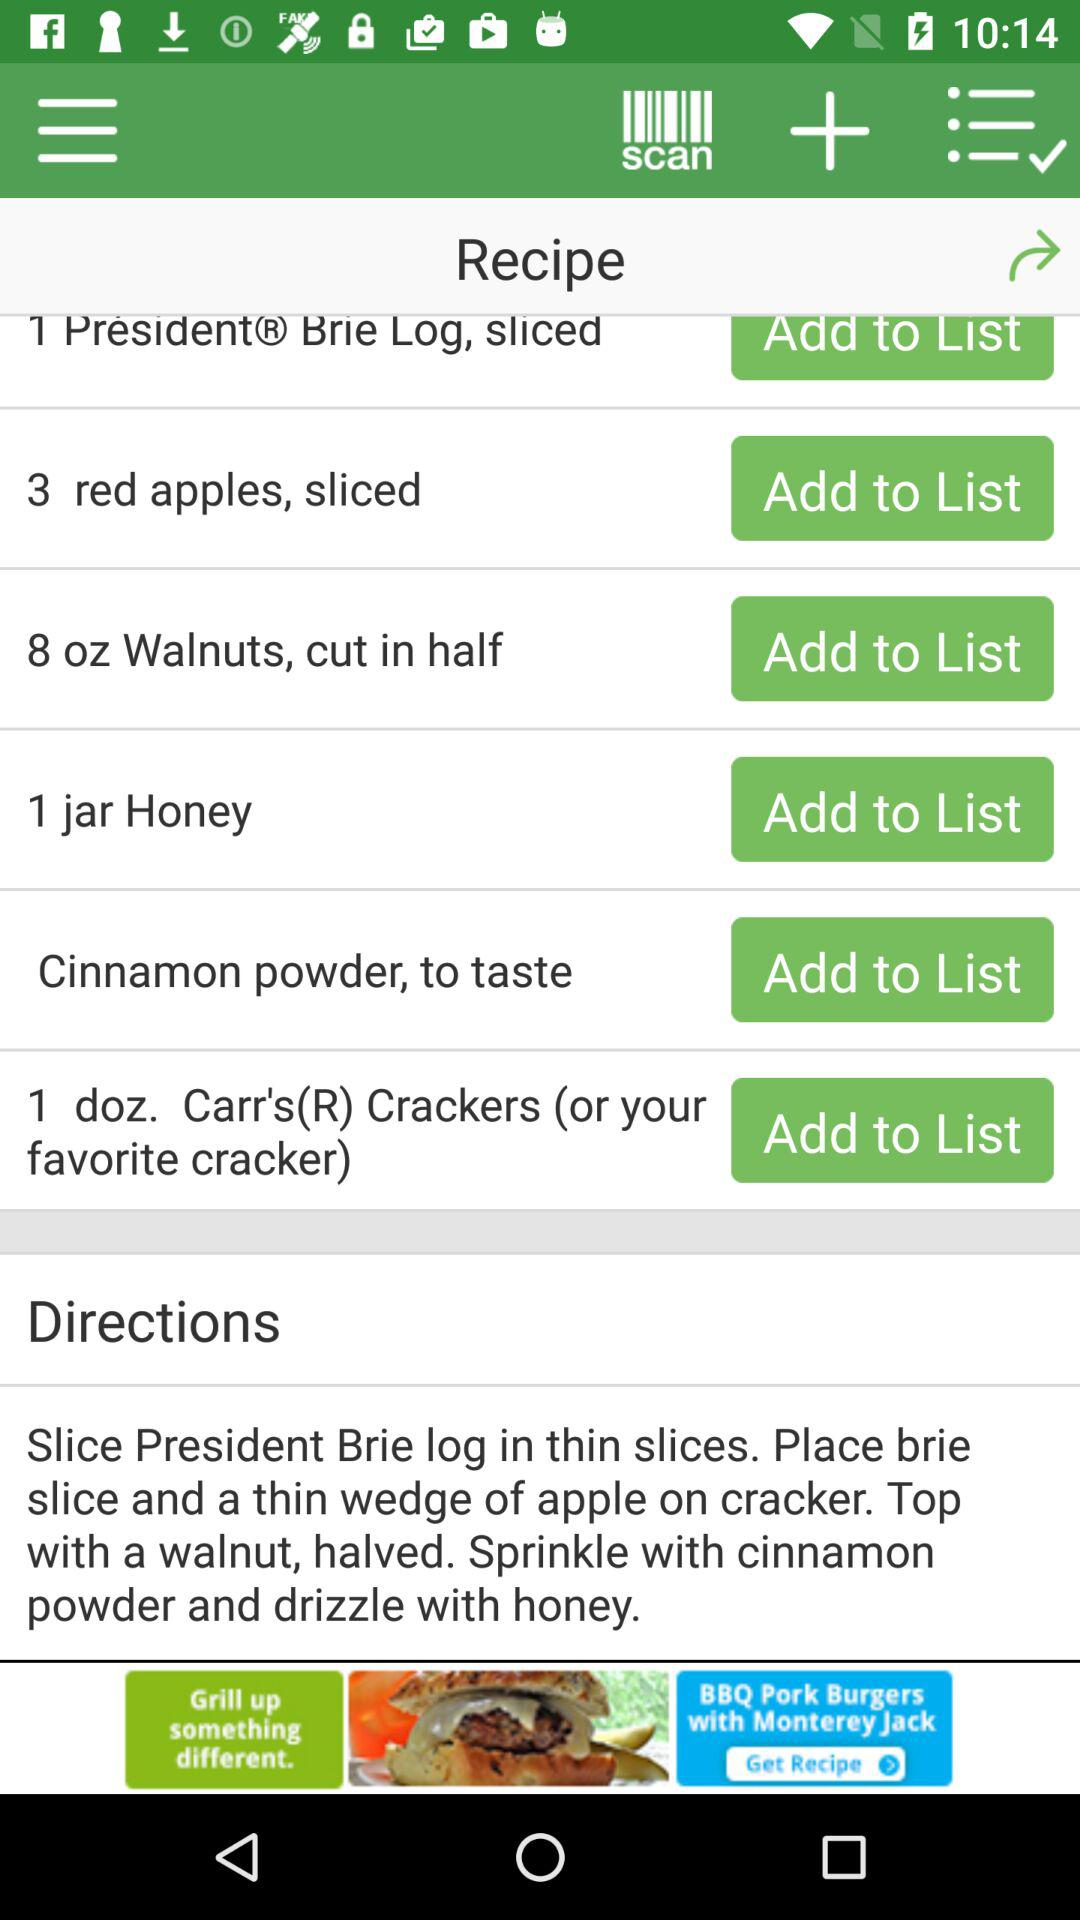What is the quantity of "Brie Log" to be added? The quantity of "Brie Log" to be added is 1. 